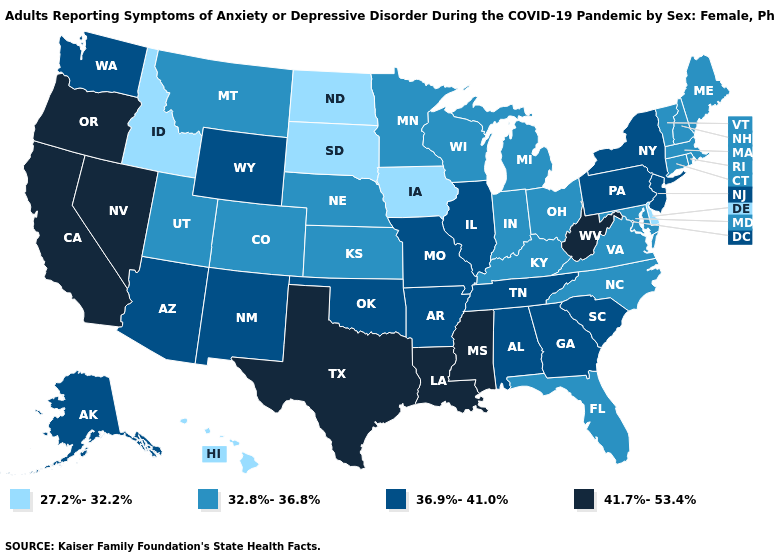What is the lowest value in the West?
Be succinct. 27.2%-32.2%. Among the states that border Oregon , does California have the highest value?
Keep it brief. Yes. Does South Carolina have the same value as Maryland?
Short answer required. No. Name the states that have a value in the range 41.7%-53.4%?
Keep it brief. California, Louisiana, Mississippi, Nevada, Oregon, Texas, West Virginia. Does Kansas have a higher value than Illinois?
Write a very short answer. No. What is the value of Louisiana?
Write a very short answer. 41.7%-53.4%. Does Oklahoma have a lower value than Florida?
Write a very short answer. No. What is the highest value in the Northeast ?
Give a very brief answer. 36.9%-41.0%. Name the states that have a value in the range 36.9%-41.0%?
Short answer required. Alabama, Alaska, Arizona, Arkansas, Georgia, Illinois, Missouri, New Jersey, New Mexico, New York, Oklahoma, Pennsylvania, South Carolina, Tennessee, Washington, Wyoming. Does North Dakota have the lowest value in the MidWest?
Concise answer only. Yes. What is the value of Maine?
Be succinct. 32.8%-36.8%. Does the map have missing data?
Give a very brief answer. No. Name the states that have a value in the range 36.9%-41.0%?
Concise answer only. Alabama, Alaska, Arizona, Arkansas, Georgia, Illinois, Missouri, New Jersey, New Mexico, New York, Oklahoma, Pennsylvania, South Carolina, Tennessee, Washington, Wyoming. Among the states that border Mississippi , does Louisiana have the highest value?
Quick response, please. Yes. 